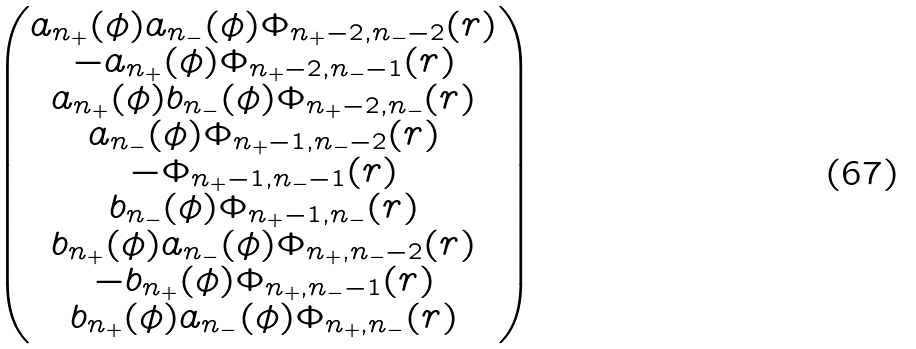Convert formula to latex. <formula><loc_0><loc_0><loc_500><loc_500>\begin{pmatrix} a _ { n _ { + } } ( \phi ) a _ { n _ { - } } ( \phi ) \Phi _ { n _ { + } - 2 , n _ { - } - 2 } ( { r } ) \\ - a _ { n _ { + } } ( \phi ) \Phi _ { n _ { + } - 2 , n _ { - } - 1 } ( { r } ) \\ a _ { n _ { + } } ( \phi ) b _ { n _ { - } } ( \phi ) \Phi _ { n _ { + } - 2 , n _ { - } } ( { r } ) \\ a _ { n _ { - } } ( \phi ) \Phi _ { n _ { + } - 1 , n _ { - } - 2 } ( { r } ) \\ - \Phi _ { n _ { + } - 1 , n _ { - } - 1 } ( { r } ) \\ b _ { n _ { - } } ( \phi ) \Phi _ { n _ { + } - 1 , n _ { - } } ( { r } ) \\ b _ { n _ { + } } ( \phi ) a _ { n _ { - } } ( \phi ) \Phi _ { n _ { + } , n _ { - } - 2 } ( { r } ) \\ - b _ { n _ { + } } ( \phi ) \Phi _ { n _ { + } , n _ { - } - 1 } ( { r } ) \\ b _ { n _ { + } } ( \phi ) a _ { n _ { - } } ( \phi ) \Phi _ { n _ { + } , n _ { - } } ( { r } ) \\ \end{pmatrix}</formula> 